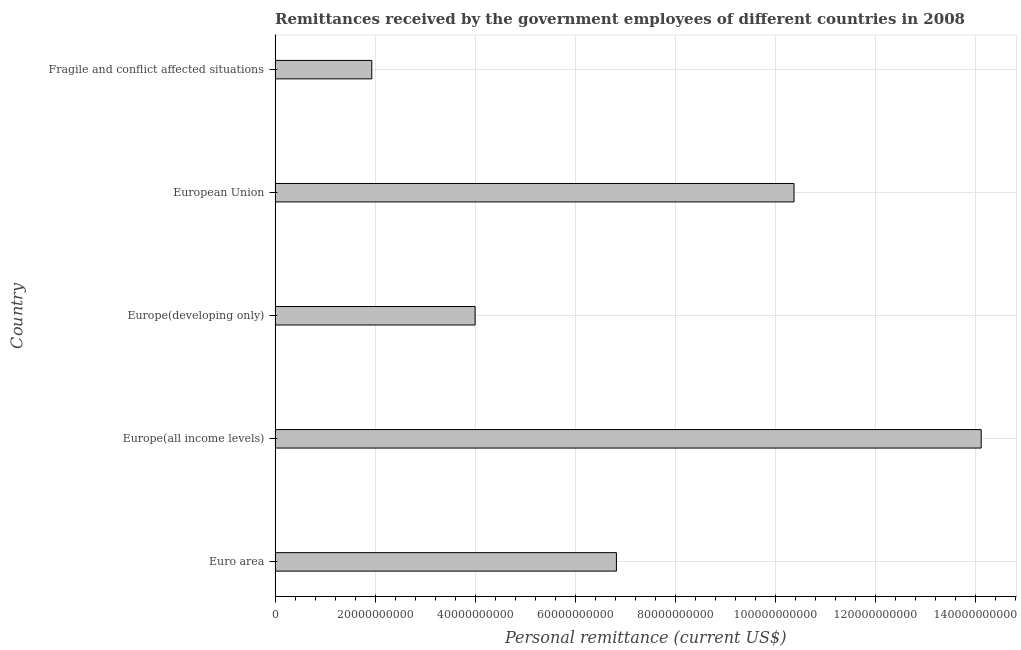Does the graph contain grids?
Offer a terse response. Yes. What is the title of the graph?
Offer a very short reply. Remittances received by the government employees of different countries in 2008. What is the label or title of the X-axis?
Keep it short and to the point. Personal remittance (current US$). What is the label or title of the Y-axis?
Offer a very short reply. Country. What is the personal remittances in European Union?
Provide a succinct answer. 1.04e+11. Across all countries, what is the maximum personal remittances?
Your response must be concise. 1.41e+11. Across all countries, what is the minimum personal remittances?
Provide a short and direct response. 1.93e+1. In which country was the personal remittances maximum?
Provide a short and direct response. Europe(all income levels). In which country was the personal remittances minimum?
Ensure brevity in your answer.  Fragile and conflict affected situations. What is the sum of the personal remittances?
Your response must be concise. 3.73e+11. What is the difference between the personal remittances in Europe(developing only) and European Union?
Your response must be concise. -6.38e+1. What is the average personal remittances per country?
Offer a terse response. 7.45e+1. What is the median personal remittances?
Give a very brief answer. 6.83e+1. What is the ratio of the personal remittances in Europe(developing only) to that in Fragile and conflict affected situations?
Ensure brevity in your answer.  2.07. What is the difference between the highest and the second highest personal remittances?
Give a very brief answer. 3.74e+1. What is the difference between the highest and the lowest personal remittances?
Make the answer very short. 1.22e+11. In how many countries, is the personal remittances greater than the average personal remittances taken over all countries?
Offer a terse response. 2. How many countries are there in the graph?
Ensure brevity in your answer.  5. What is the Personal remittance (current US$) in Euro area?
Ensure brevity in your answer.  6.83e+1. What is the Personal remittance (current US$) of Europe(all income levels)?
Offer a terse response. 1.41e+11. What is the Personal remittance (current US$) of Europe(developing only)?
Offer a terse response. 4.00e+1. What is the Personal remittance (current US$) in European Union?
Provide a succinct answer. 1.04e+11. What is the Personal remittance (current US$) of Fragile and conflict affected situations?
Provide a short and direct response. 1.93e+1. What is the difference between the Personal remittance (current US$) in Euro area and Europe(all income levels)?
Give a very brief answer. -7.29e+1. What is the difference between the Personal remittance (current US$) in Euro area and Europe(developing only)?
Your answer should be very brief. 2.83e+1. What is the difference between the Personal remittance (current US$) in Euro area and European Union?
Offer a terse response. -3.55e+1. What is the difference between the Personal remittance (current US$) in Euro area and Fragile and conflict affected situations?
Your response must be concise. 4.89e+1. What is the difference between the Personal remittance (current US$) in Europe(all income levels) and Europe(developing only)?
Make the answer very short. 1.01e+11. What is the difference between the Personal remittance (current US$) in Europe(all income levels) and European Union?
Your response must be concise. 3.74e+1. What is the difference between the Personal remittance (current US$) in Europe(all income levels) and Fragile and conflict affected situations?
Your response must be concise. 1.22e+11. What is the difference between the Personal remittance (current US$) in Europe(developing only) and European Union?
Offer a terse response. -6.38e+1. What is the difference between the Personal remittance (current US$) in Europe(developing only) and Fragile and conflict affected situations?
Make the answer very short. 2.07e+1. What is the difference between the Personal remittance (current US$) in European Union and Fragile and conflict affected situations?
Offer a very short reply. 8.44e+1. What is the ratio of the Personal remittance (current US$) in Euro area to that in Europe(all income levels)?
Your answer should be compact. 0.48. What is the ratio of the Personal remittance (current US$) in Euro area to that in Europe(developing only)?
Give a very brief answer. 1.71. What is the ratio of the Personal remittance (current US$) in Euro area to that in European Union?
Give a very brief answer. 0.66. What is the ratio of the Personal remittance (current US$) in Euro area to that in Fragile and conflict affected situations?
Your answer should be very brief. 3.53. What is the ratio of the Personal remittance (current US$) in Europe(all income levels) to that in Europe(developing only)?
Offer a very short reply. 3.53. What is the ratio of the Personal remittance (current US$) in Europe(all income levels) to that in European Union?
Give a very brief answer. 1.36. What is the ratio of the Personal remittance (current US$) in Europe(all income levels) to that in Fragile and conflict affected situations?
Provide a succinct answer. 7.3. What is the ratio of the Personal remittance (current US$) in Europe(developing only) to that in European Union?
Your answer should be very brief. 0.39. What is the ratio of the Personal remittance (current US$) in Europe(developing only) to that in Fragile and conflict affected situations?
Offer a terse response. 2.07. What is the ratio of the Personal remittance (current US$) in European Union to that in Fragile and conflict affected situations?
Offer a terse response. 5.37. 